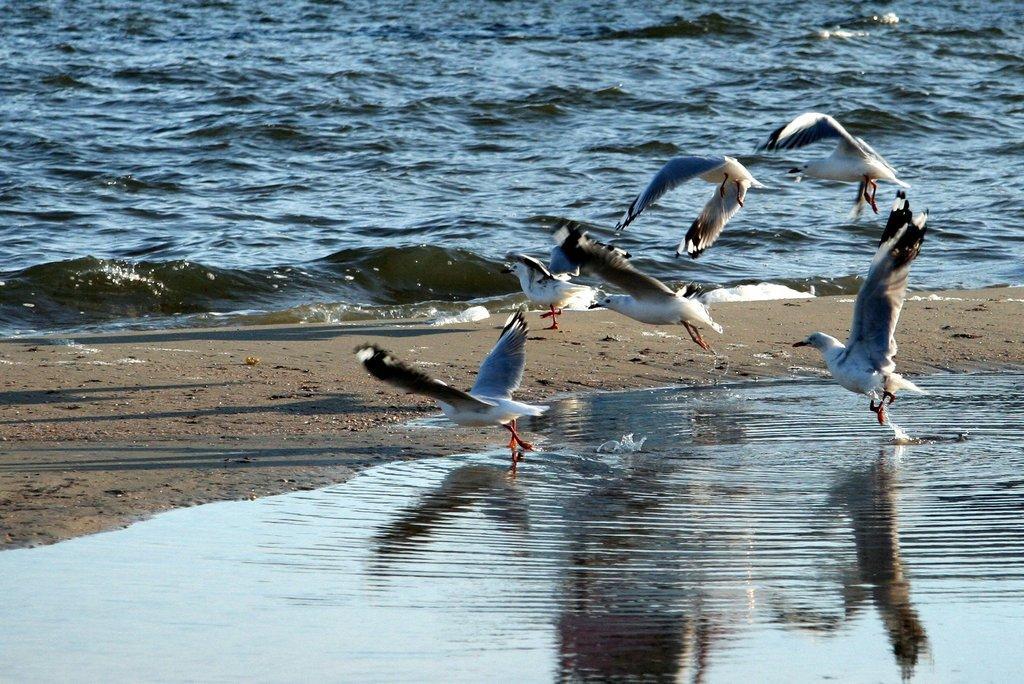Describe this image in one or two sentences. In this image we can see a group of birds. In the background, we can see water. 